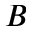Convert formula to latex. <formula><loc_0><loc_0><loc_500><loc_500>B</formula> 